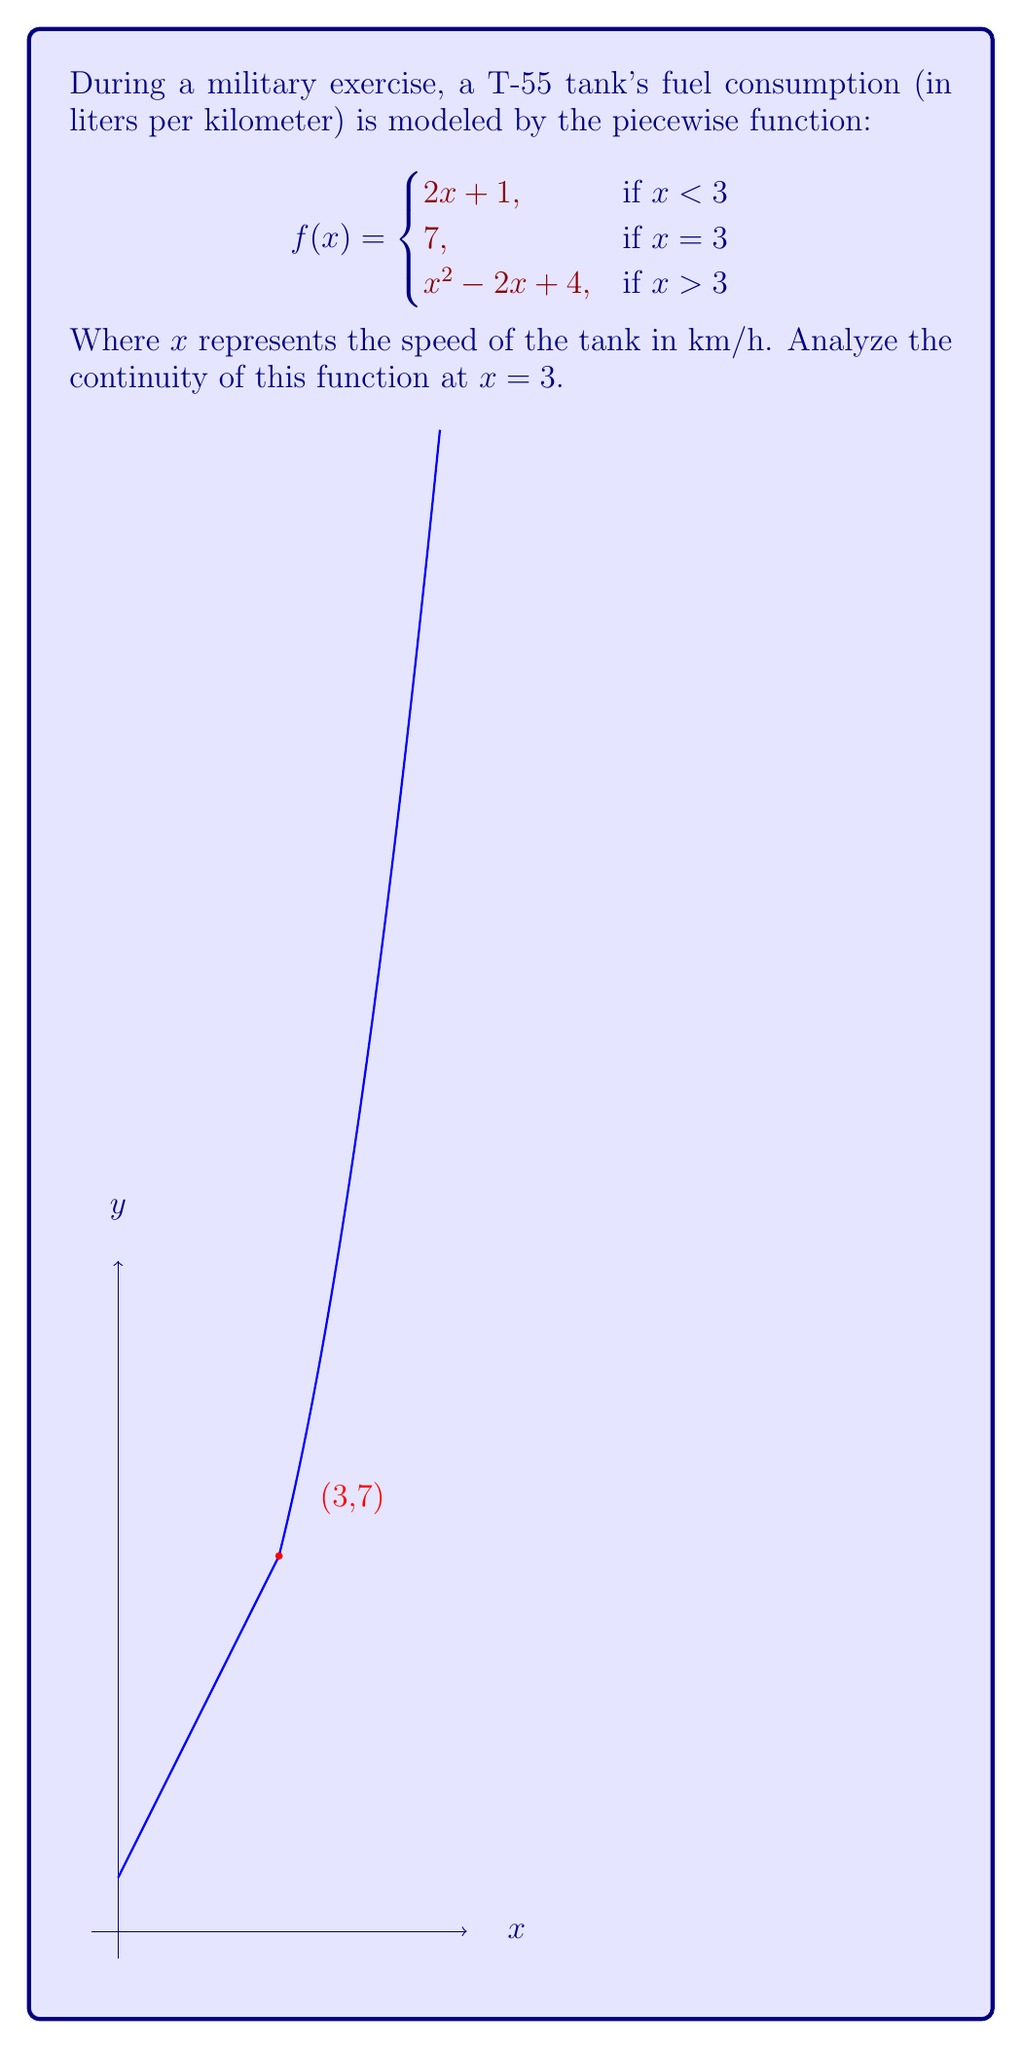Can you answer this question? To analyze the continuity of the function at $x = 3$, we need to check three conditions:

1) The function must be defined at $x = 3$:
   $f(3) = 7$, so this condition is satisfied.

2) The limit of the function as $x$ approaches 3 from the left must exist:
   $\lim_{x \to 3^-} f(x) = \lim_{x \to 3^-} (2x + 1) = 2(3) + 1 = 7$

3) The limit of the function as $x$ approaches 3 from the right must exist:
   $\lim_{x \to 3^+} f(x) = \lim_{x \to 3^+} (x^2 - 2x + 4) = 3^2 - 2(3) + 4 = 7$

4) Both one-sided limits must be equal to the function value at $x = 3$:
   $\lim_{x \to 3^-} f(x) = \lim_{x \to 3^+} f(x) = f(3) = 7$

Since all conditions are satisfied, the function is continuous at $x = 3$.
Answer: The function is continuous at $x = 3$. 